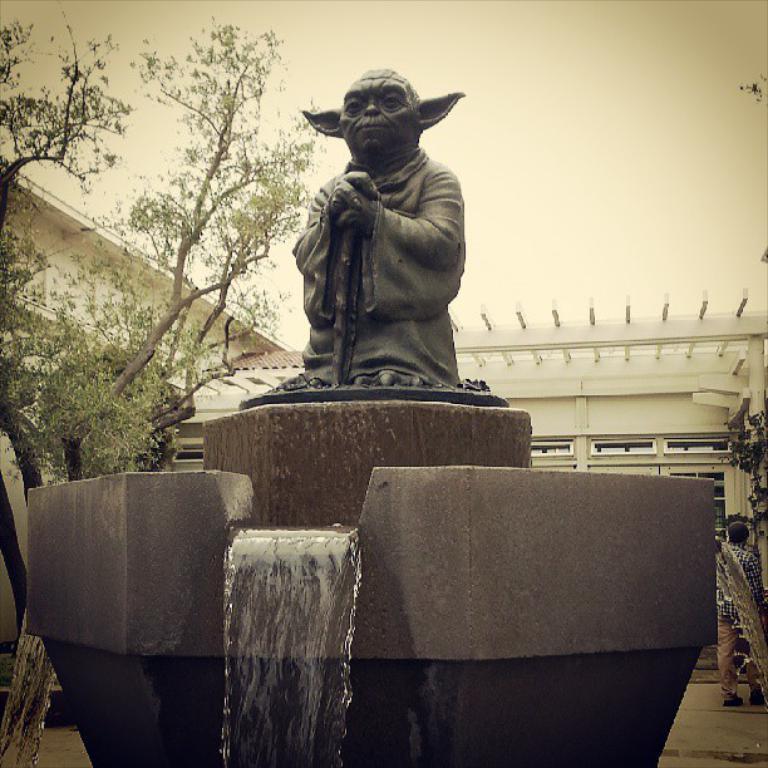Describe this image in one or two sentences. In this picture there is a statue and fountain in the foreground. At the back there is a building and there are trees. On the right side of the image there is a person standing. At the top there is sky. 